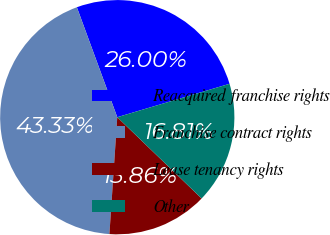<chart> <loc_0><loc_0><loc_500><loc_500><pie_chart><fcel>Reacquired franchise rights<fcel>Franchise contract rights<fcel>Lease tenancy rights<fcel>Other<nl><fcel>26.0%<fcel>43.33%<fcel>13.86%<fcel>16.81%<nl></chart> 